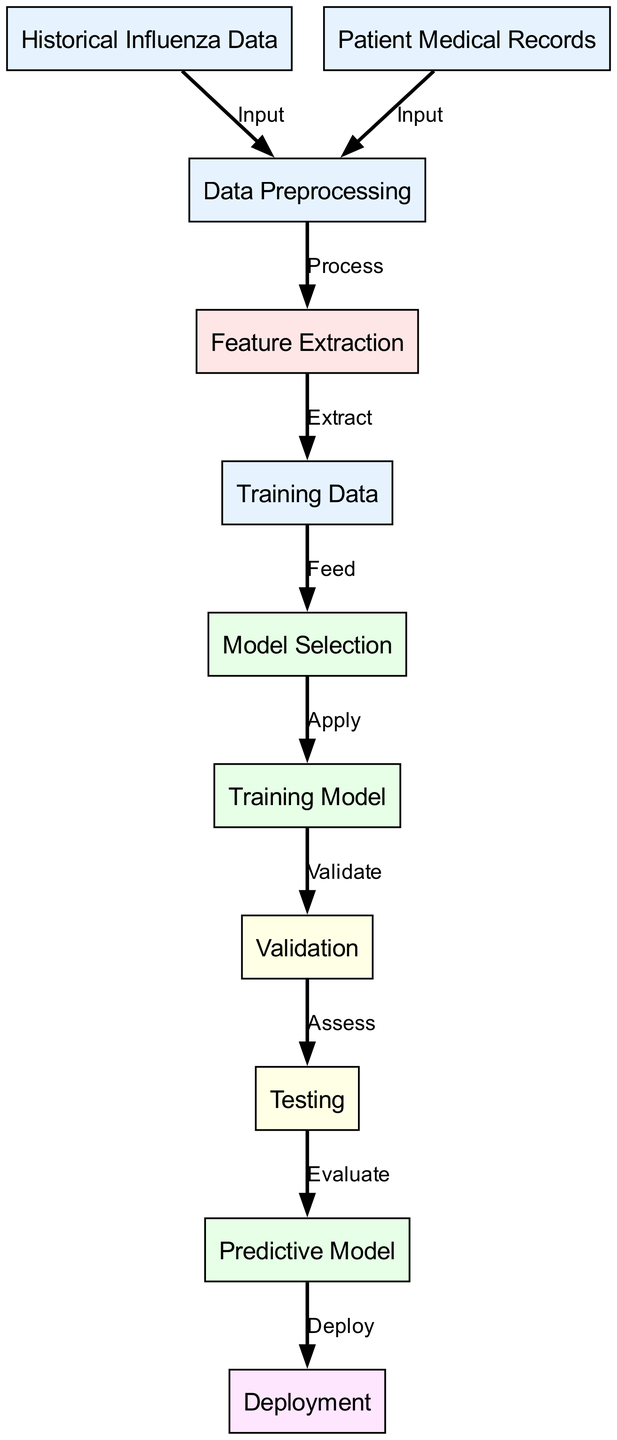What are the two sources of input in the diagram? The diagram indicates two nodes labeled "Historical Influenza Data" and "Patient Medical Records" as sources of input, both feeding into the "Data Preprocessing" node.
Answer: Historical Influenza Data, Patient Medical Records How many nodes represent the evaluation stages in the diagram? The evaluation stages in the diagram are represented by two nodes: "Validation" and "Testing". Therefore, the total is two evaluation nodes.
Answer: 2 Which node directly follows the "Feature Extraction" node? After the "Feature Extraction" node, the diagram shows a direct connection to the "Training Data" node, indicating the next step in the process.
Answer: Training Data What is the function of the "Model Selection" node? The "Model Selection" node is responsible for determining the best model to apply based on the training data provided to it, which is shown by the edge labeled "Apply".
Answer: Apply What is the last node before deployment in the diagram? The last node before deployment in the diagram is the "Predictive Model", which indicates the final outcome of the machine learning process after going through validation and testing.
Answer: Predictive Model Which two nodes are categorized as input components? The input components are categorized as "Historical Influenza Data" and "Patient Medical Records" nodes, both of which lead into preprocessing.
Answer: Historical Influenza Data, Patient Medical Records How does the "Validation" node connect to the "Testing" node? The "Validation" node connects to the "Testing" node through an edge labeled "Assess", indicating that assessment follows validation in the flow of the diagram.
Answer: Assess What process occurs between "Data Preprocessing" and "Feature Extraction"? The process that occurs between "Data Preprocessing" and "Feature Extraction" is indicated by the labeled edge "Process", which represents the transformation of raw data into a more usable format for feature extraction.
Answer: Process 